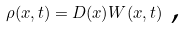<formula> <loc_0><loc_0><loc_500><loc_500>\rho ( x , t ) = D ( x ) W ( x , t ) \text { ,}</formula> 